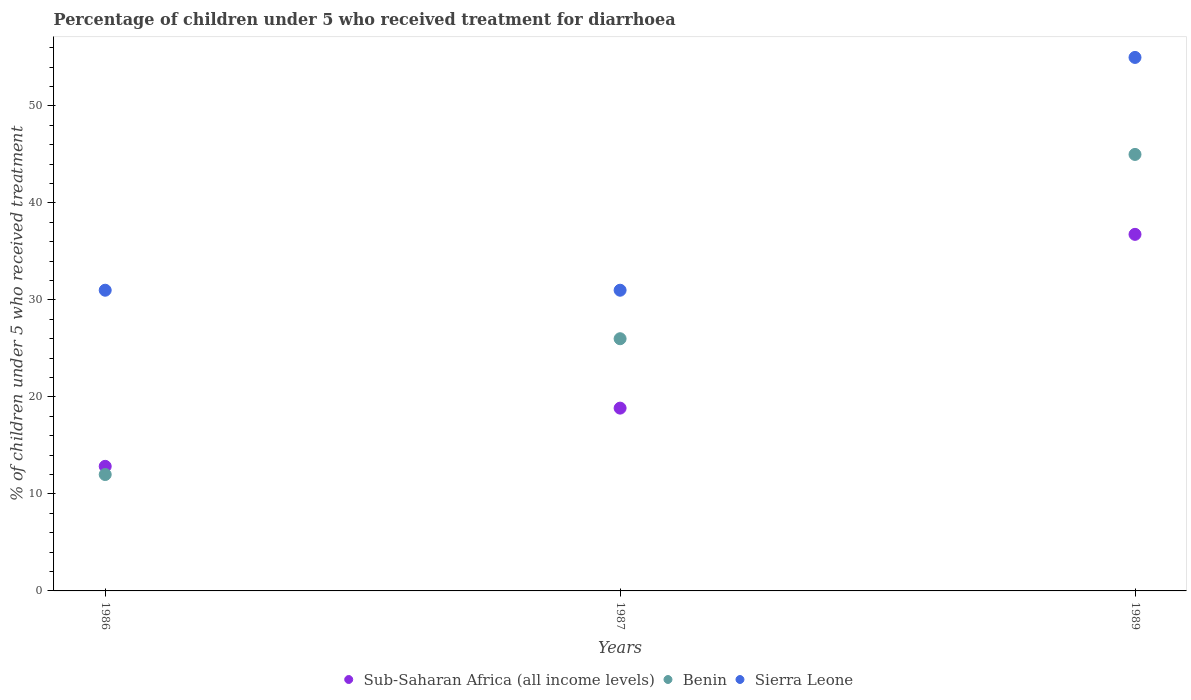Across all years, what is the maximum percentage of children who received treatment for diarrhoea  in Sub-Saharan Africa (all income levels)?
Offer a terse response. 36.76. In which year was the percentage of children who received treatment for diarrhoea  in Sub-Saharan Africa (all income levels) minimum?
Provide a short and direct response. 1986. What is the total percentage of children who received treatment for diarrhoea  in Sierra Leone in the graph?
Offer a very short reply. 117. What is the difference between the percentage of children who received treatment for diarrhoea  in Benin in 1986 and that in 1989?
Your response must be concise. -33. What is the difference between the percentage of children who received treatment for diarrhoea  in Benin in 1989 and the percentage of children who received treatment for diarrhoea  in Sub-Saharan Africa (all income levels) in 1987?
Your response must be concise. 26.15. In the year 1987, what is the difference between the percentage of children who received treatment for diarrhoea  in Sub-Saharan Africa (all income levels) and percentage of children who received treatment for diarrhoea  in Sierra Leone?
Give a very brief answer. -12.15. What is the ratio of the percentage of children who received treatment for diarrhoea  in Sierra Leone in 1986 to that in 1987?
Provide a short and direct response. 1. Is the percentage of children who received treatment for diarrhoea  in Benin in 1986 less than that in 1989?
Provide a succinct answer. Yes. Is the difference between the percentage of children who received treatment for diarrhoea  in Sub-Saharan Africa (all income levels) in 1986 and 1989 greater than the difference between the percentage of children who received treatment for diarrhoea  in Sierra Leone in 1986 and 1989?
Make the answer very short. Yes. What is the difference between the highest and the second highest percentage of children who received treatment for diarrhoea  in Sierra Leone?
Ensure brevity in your answer.  24. What is the difference between the highest and the lowest percentage of children who received treatment for diarrhoea  in Benin?
Make the answer very short. 33. In how many years, is the percentage of children who received treatment for diarrhoea  in Sierra Leone greater than the average percentage of children who received treatment for diarrhoea  in Sierra Leone taken over all years?
Provide a succinct answer. 1. Is the sum of the percentage of children who received treatment for diarrhoea  in Benin in 1986 and 1989 greater than the maximum percentage of children who received treatment for diarrhoea  in Sierra Leone across all years?
Offer a terse response. Yes. How many dotlines are there?
Your answer should be compact. 3. How many years are there in the graph?
Keep it short and to the point. 3. Does the graph contain any zero values?
Provide a short and direct response. No. How many legend labels are there?
Provide a short and direct response. 3. How are the legend labels stacked?
Ensure brevity in your answer.  Horizontal. What is the title of the graph?
Ensure brevity in your answer.  Percentage of children under 5 who received treatment for diarrhoea. What is the label or title of the X-axis?
Offer a terse response. Years. What is the label or title of the Y-axis?
Provide a succinct answer. % of children under 5 who received treatment. What is the % of children under 5 who received treatment in Sub-Saharan Africa (all income levels) in 1986?
Offer a very short reply. 12.84. What is the % of children under 5 who received treatment in Benin in 1986?
Provide a short and direct response. 12. What is the % of children under 5 who received treatment of Sub-Saharan Africa (all income levels) in 1987?
Offer a terse response. 18.85. What is the % of children under 5 who received treatment in Benin in 1987?
Ensure brevity in your answer.  26. What is the % of children under 5 who received treatment in Sub-Saharan Africa (all income levels) in 1989?
Ensure brevity in your answer.  36.76. What is the % of children under 5 who received treatment of Benin in 1989?
Ensure brevity in your answer.  45. Across all years, what is the maximum % of children under 5 who received treatment of Sub-Saharan Africa (all income levels)?
Give a very brief answer. 36.76. Across all years, what is the maximum % of children under 5 who received treatment of Sierra Leone?
Provide a succinct answer. 55. Across all years, what is the minimum % of children under 5 who received treatment in Sub-Saharan Africa (all income levels)?
Provide a succinct answer. 12.84. Across all years, what is the minimum % of children under 5 who received treatment of Benin?
Your answer should be very brief. 12. What is the total % of children under 5 who received treatment of Sub-Saharan Africa (all income levels) in the graph?
Your answer should be compact. 68.45. What is the total % of children under 5 who received treatment of Benin in the graph?
Give a very brief answer. 83. What is the total % of children under 5 who received treatment of Sierra Leone in the graph?
Ensure brevity in your answer.  117. What is the difference between the % of children under 5 who received treatment of Sub-Saharan Africa (all income levels) in 1986 and that in 1987?
Your answer should be compact. -6. What is the difference between the % of children under 5 who received treatment of Sub-Saharan Africa (all income levels) in 1986 and that in 1989?
Your response must be concise. -23.92. What is the difference between the % of children under 5 who received treatment of Benin in 1986 and that in 1989?
Ensure brevity in your answer.  -33. What is the difference between the % of children under 5 who received treatment of Sub-Saharan Africa (all income levels) in 1987 and that in 1989?
Provide a succinct answer. -17.91. What is the difference between the % of children under 5 who received treatment in Sub-Saharan Africa (all income levels) in 1986 and the % of children under 5 who received treatment in Benin in 1987?
Make the answer very short. -13.16. What is the difference between the % of children under 5 who received treatment in Sub-Saharan Africa (all income levels) in 1986 and the % of children under 5 who received treatment in Sierra Leone in 1987?
Give a very brief answer. -18.16. What is the difference between the % of children under 5 who received treatment in Sub-Saharan Africa (all income levels) in 1986 and the % of children under 5 who received treatment in Benin in 1989?
Your response must be concise. -32.16. What is the difference between the % of children under 5 who received treatment in Sub-Saharan Africa (all income levels) in 1986 and the % of children under 5 who received treatment in Sierra Leone in 1989?
Ensure brevity in your answer.  -42.16. What is the difference between the % of children under 5 who received treatment of Benin in 1986 and the % of children under 5 who received treatment of Sierra Leone in 1989?
Offer a terse response. -43. What is the difference between the % of children under 5 who received treatment in Sub-Saharan Africa (all income levels) in 1987 and the % of children under 5 who received treatment in Benin in 1989?
Give a very brief answer. -26.15. What is the difference between the % of children under 5 who received treatment of Sub-Saharan Africa (all income levels) in 1987 and the % of children under 5 who received treatment of Sierra Leone in 1989?
Ensure brevity in your answer.  -36.15. What is the difference between the % of children under 5 who received treatment in Benin in 1987 and the % of children under 5 who received treatment in Sierra Leone in 1989?
Your answer should be compact. -29. What is the average % of children under 5 who received treatment in Sub-Saharan Africa (all income levels) per year?
Give a very brief answer. 22.82. What is the average % of children under 5 who received treatment in Benin per year?
Make the answer very short. 27.67. In the year 1986, what is the difference between the % of children under 5 who received treatment of Sub-Saharan Africa (all income levels) and % of children under 5 who received treatment of Benin?
Provide a short and direct response. 0.84. In the year 1986, what is the difference between the % of children under 5 who received treatment of Sub-Saharan Africa (all income levels) and % of children under 5 who received treatment of Sierra Leone?
Your response must be concise. -18.16. In the year 1987, what is the difference between the % of children under 5 who received treatment in Sub-Saharan Africa (all income levels) and % of children under 5 who received treatment in Benin?
Your answer should be very brief. -7.15. In the year 1987, what is the difference between the % of children under 5 who received treatment in Sub-Saharan Africa (all income levels) and % of children under 5 who received treatment in Sierra Leone?
Provide a short and direct response. -12.15. In the year 1987, what is the difference between the % of children under 5 who received treatment in Benin and % of children under 5 who received treatment in Sierra Leone?
Keep it short and to the point. -5. In the year 1989, what is the difference between the % of children under 5 who received treatment of Sub-Saharan Africa (all income levels) and % of children under 5 who received treatment of Benin?
Make the answer very short. -8.24. In the year 1989, what is the difference between the % of children under 5 who received treatment of Sub-Saharan Africa (all income levels) and % of children under 5 who received treatment of Sierra Leone?
Offer a very short reply. -18.24. What is the ratio of the % of children under 5 who received treatment in Sub-Saharan Africa (all income levels) in 1986 to that in 1987?
Make the answer very short. 0.68. What is the ratio of the % of children under 5 who received treatment of Benin in 1986 to that in 1987?
Your answer should be very brief. 0.46. What is the ratio of the % of children under 5 who received treatment in Sierra Leone in 1986 to that in 1987?
Keep it short and to the point. 1. What is the ratio of the % of children under 5 who received treatment in Sub-Saharan Africa (all income levels) in 1986 to that in 1989?
Provide a short and direct response. 0.35. What is the ratio of the % of children under 5 who received treatment in Benin in 1986 to that in 1989?
Your answer should be very brief. 0.27. What is the ratio of the % of children under 5 who received treatment of Sierra Leone in 1986 to that in 1989?
Provide a short and direct response. 0.56. What is the ratio of the % of children under 5 who received treatment of Sub-Saharan Africa (all income levels) in 1987 to that in 1989?
Offer a terse response. 0.51. What is the ratio of the % of children under 5 who received treatment in Benin in 1987 to that in 1989?
Provide a succinct answer. 0.58. What is the ratio of the % of children under 5 who received treatment of Sierra Leone in 1987 to that in 1989?
Your response must be concise. 0.56. What is the difference between the highest and the second highest % of children under 5 who received treatment in Sub-Saharan Africa (all income levels)?
Your response must be concise. 17.91. What is the difference between the highest and the second highest % of children under 5 who received treatment of Sierra Leone?
Your answer should be compact. 24. What is the difference between the highest and the lowest % of children under 5 who received treatment of Sub-Saharan Africa (all income levels)?
Offer a terse response. 23.92. 